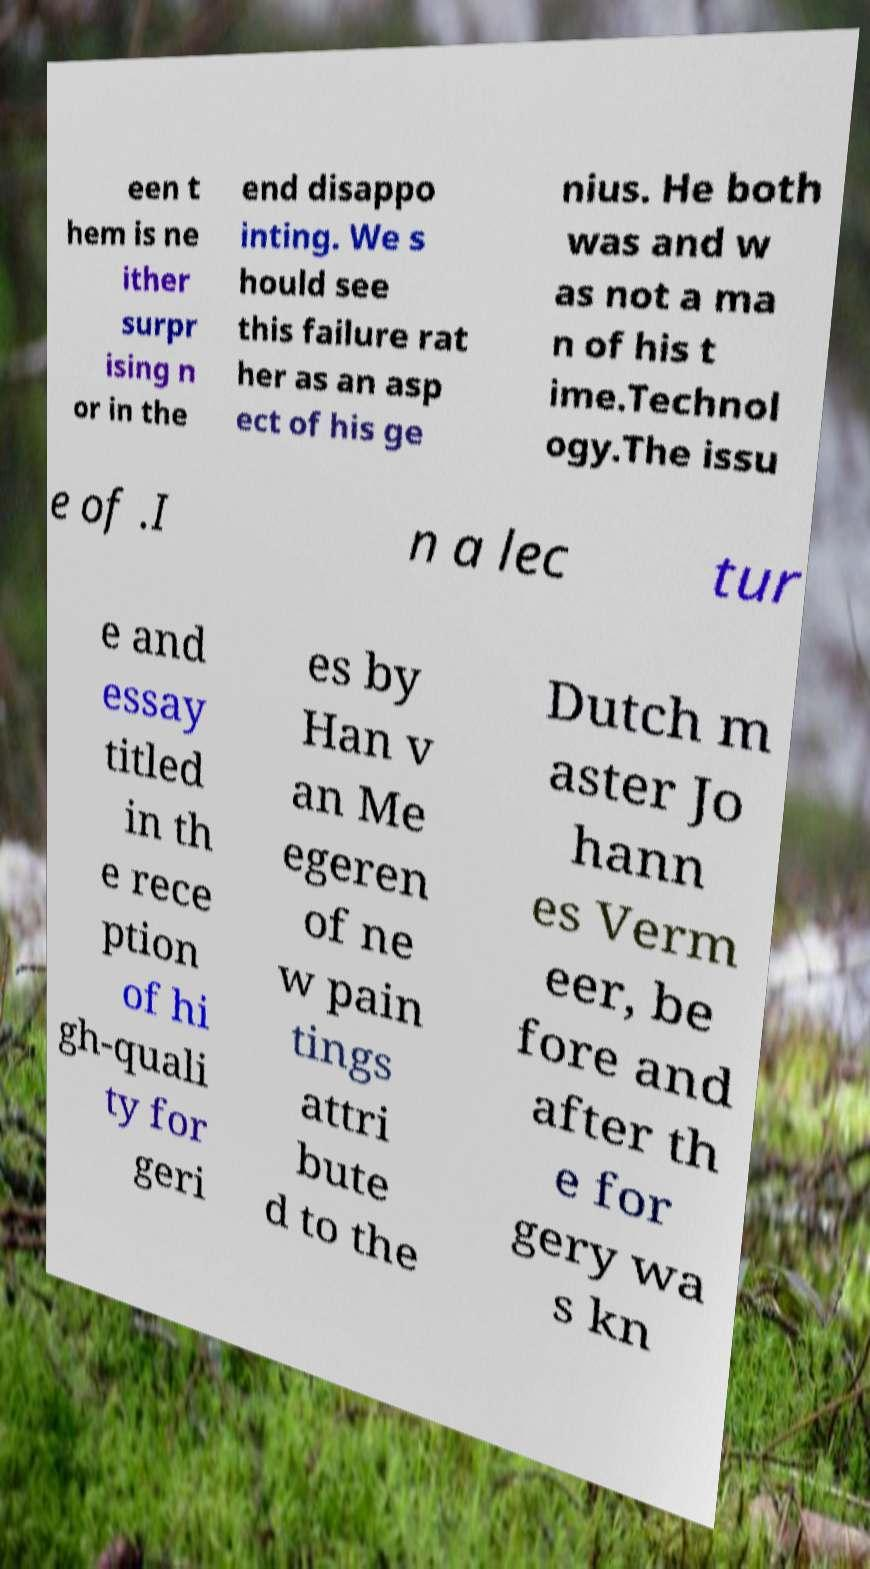Could you assist in decoding the text presented in this image and type it out clearly? een t hem is ne ither surpr ising n or in the end disappo inting. We s hould see this failure rat her as an asp ect of his ge nius. He both was and w as not a ma n of his t ime.Technol ogy.The issu e of .I n a lec tur e and essay titled in th e rece ption of hi gh-quali ty for geri es by Han v an Me egeren of ne w pain tings attri bute d to the Dutch m aster Jo hann es Verm eer, be fore and after th e for gery wa s kn 